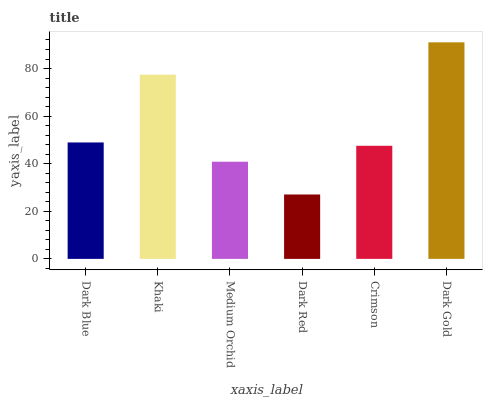Is Dark Red the minimum?
Answer yes or no. Yes. Is Dark Gold the maximum?
Answer yes or no. Yes. Is Khaki the minimum?
Answer yes or no. No. Is Khaki the maximum?
Answer yes or no. No. Is Khaki greater than Dark Blue?
Answer yes or no. Yes. Is Dark Blue less than Khaki?
Answer yes or no. Yes. Is Dark Blue greater than Khaki?
Answer yes or no. No. Is Khaki less than Dark Blue?
Answer yes or no. No. Is Dark Blue the high median?
Answer yes or no. Yes. Is Crimson the low median?
Answer yes or no. Yes. Is Medium Orchid the high median?
Answer yes or no. No. Is Dark Red the low median?
Answer yes or no. No. 